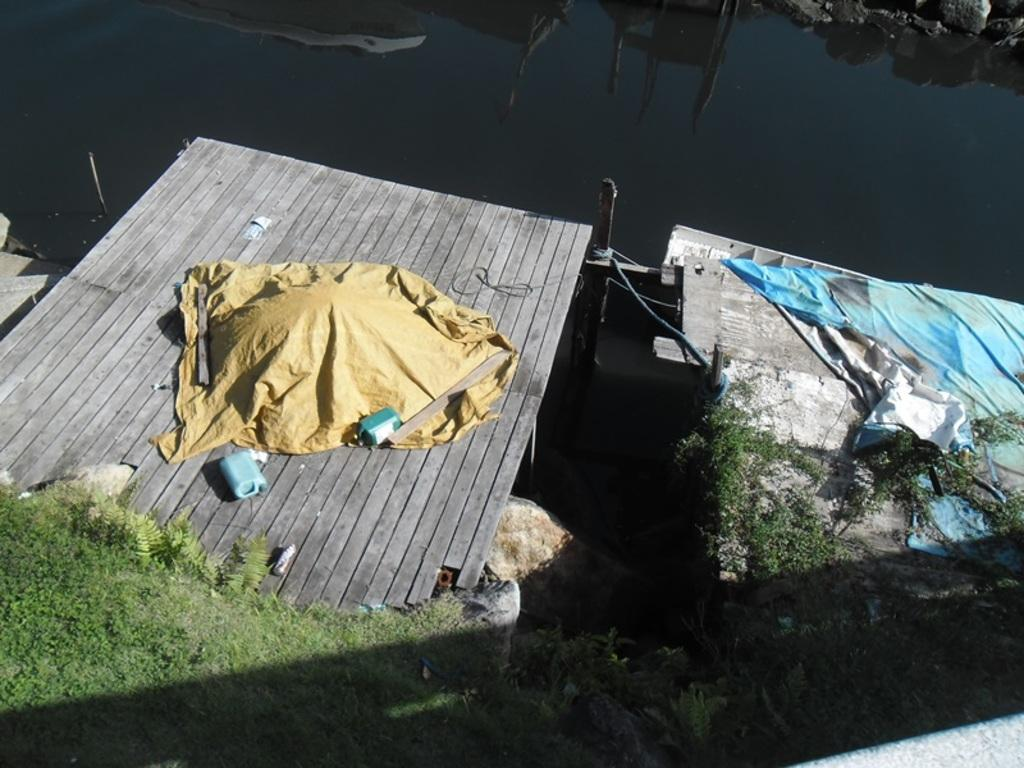What type of body of water is present in the image? There is a lake in the image. What structure can be seen crossing the lake? There is a wooden bridge in the image. Can you describe what is on the wooden bridge? There are some unspecified things on the bridge. What type of cake is being served by the minister on the wooden bridge in the image? There is no minister or cake present in the image. What type of patch is visible on the wooden bridge in the image? There is no patch visible on the wooden bridge in the image. 